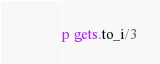<code> <loc_0><loc_0><loc_500><loc_500><_Ruby_>p gets.to_i/3</code> 